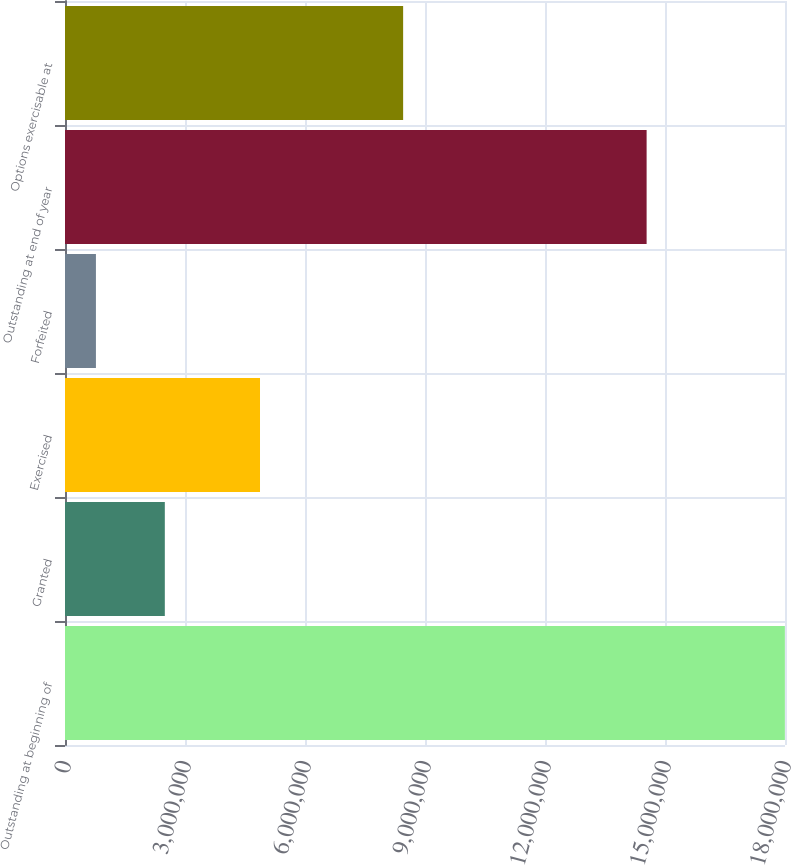<chart> <loc_0><loc_0><loc_500><loc_500><bar_chart><fcel>Outstanding at beginning of<fcel>Granted<fcel>Exercised<fcel>Forfeited<fcel>Outstanding at end of year<fcel>Options exercisable at<nl><fcel>1.79971e+07<fcel>2.49554e+06<fcel>4.87512e+06<fcel>773145<fcel>1.45404e+07<fcel>8.45336e+06<nl></chart> 